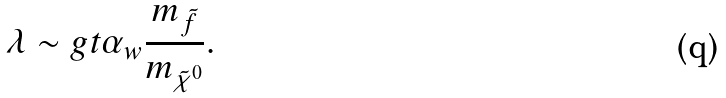Convert formula to latex. <formula><loc_0><loc_0><loc_500><loc_500>\lambda \sim g t \alpha _ { w } \frac { m _ { \tilde { f } } } { m _ { \tilde { \chi } ^ { 0 } } } .</formula> 